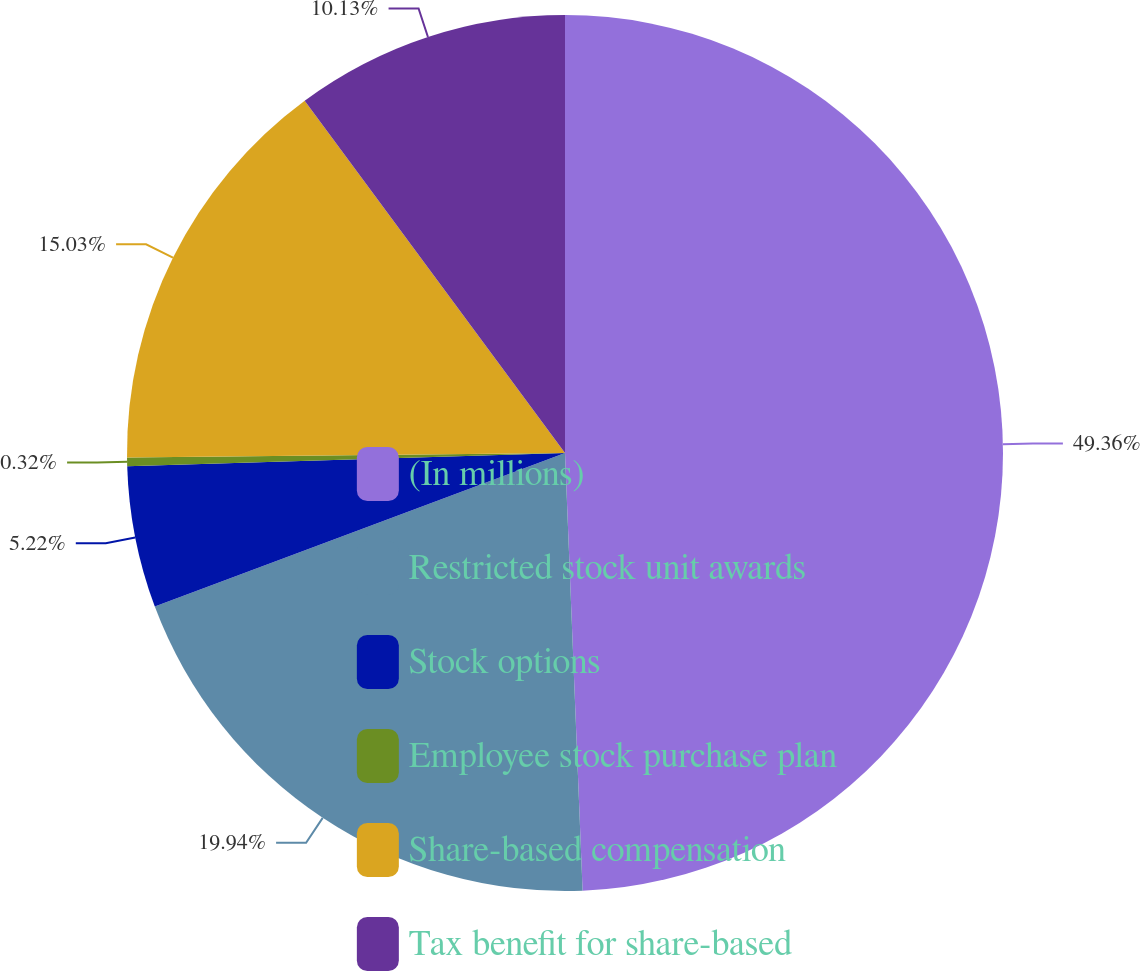<chart> <loc_0><loc_0><loc_500><loc_500><pie_chart><fcel>(In millions)<fcel>Restricted stock unit awards<fcel>Stock options<fcel>Employee stock purchase plan<fcel>Share-based compensation<fcel>Tax benefit for share-based<nl><fcel>49.36%<fcel>19.94%<fcel>5.22%<fcel>0.32%<fcel>15.03%<fcel>10.13%<nl></chart> 